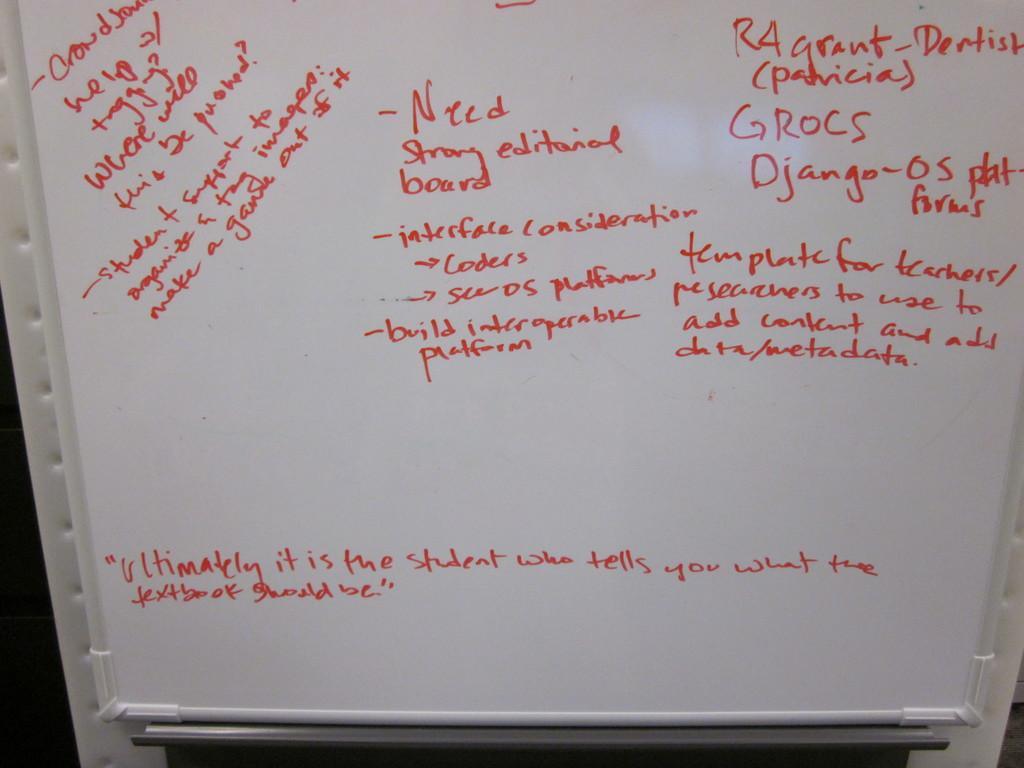What does the bottom quote say?
Ensure brevity in your answer.  Ultimately it is the student who tells you what the textbook should be. 